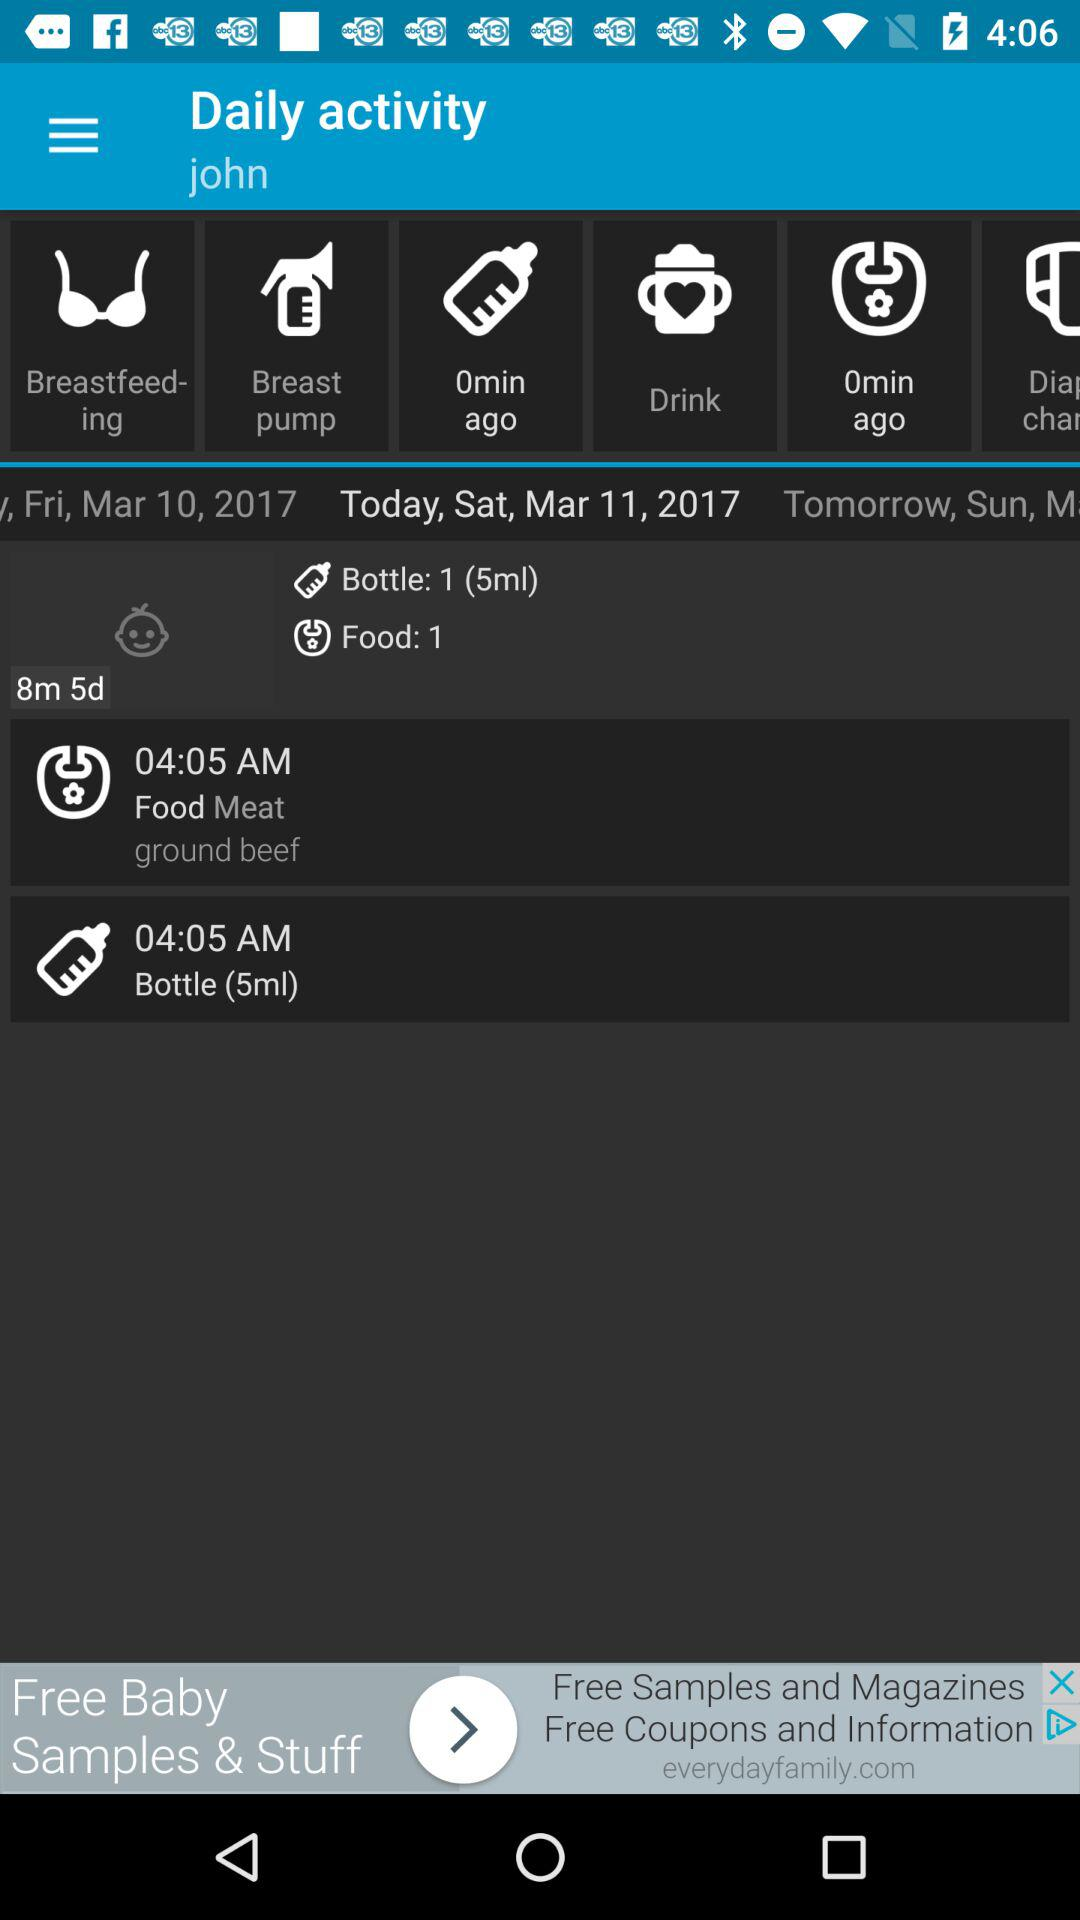What is the selected date? The selected date is Saturday, March 11, 2017. 